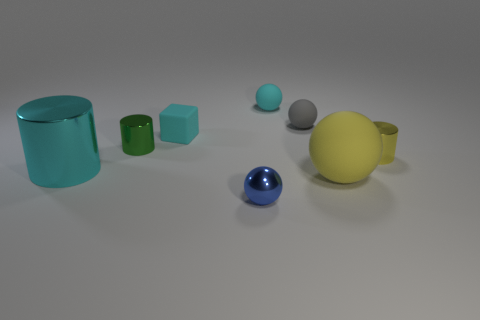There is a tiny rubber object that is the same color as the rubber cube; what is its shape?
Offer a terse response. Sphere. What number of cyan objects are the same size as the cyan metallic cylinder?
Offer a very short reply. 0. There is a big yellow matte thing that is in front of the green metal cylinder; what shape is it?
Make the answer very short. Sphere. Are there fewer big yellow objects than brown metallic things?
Make the answer very short. No. Is there any other thing that has the same color as the big shiny thing?
Make the answer very short. Yes. How big is the metal object in front of the large metallic cylinder?
Your answer should be compact. Small. Is the number of blue matte cylinders greater than the number of small shiny cylinders?
Ensure brevity in your answer.  No. What is the small cyan ball made of?
Give a very brief answer. Rubber. How many other objects are there of the same material as the tiny cyan block?
Your answer should be compact. 3. What number of large metallic cylinders are there?
Your response must be concise. 1. 